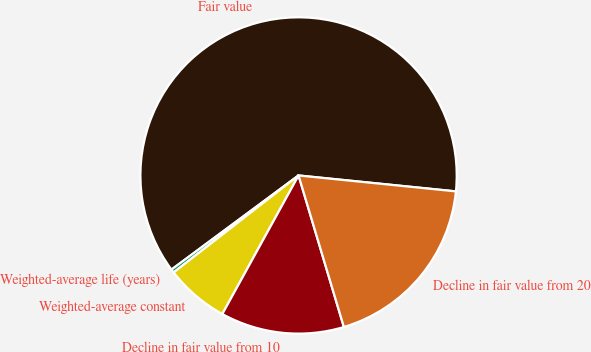Convert chart. <chart><loc_0><loc_0><loc_500><loc_500><pie_chart><fcel>Fair value<fcel>Weighted-average life (years)<fcel>Weighted-average constant<fcel>Decline in fair value from 10<fcel>Decline in fair value from 20<nl><fcel>61.75%<fcel>0.36%<fcel>6.49%<fcel>12.63%<fcel>18.77%<nl></chart> 